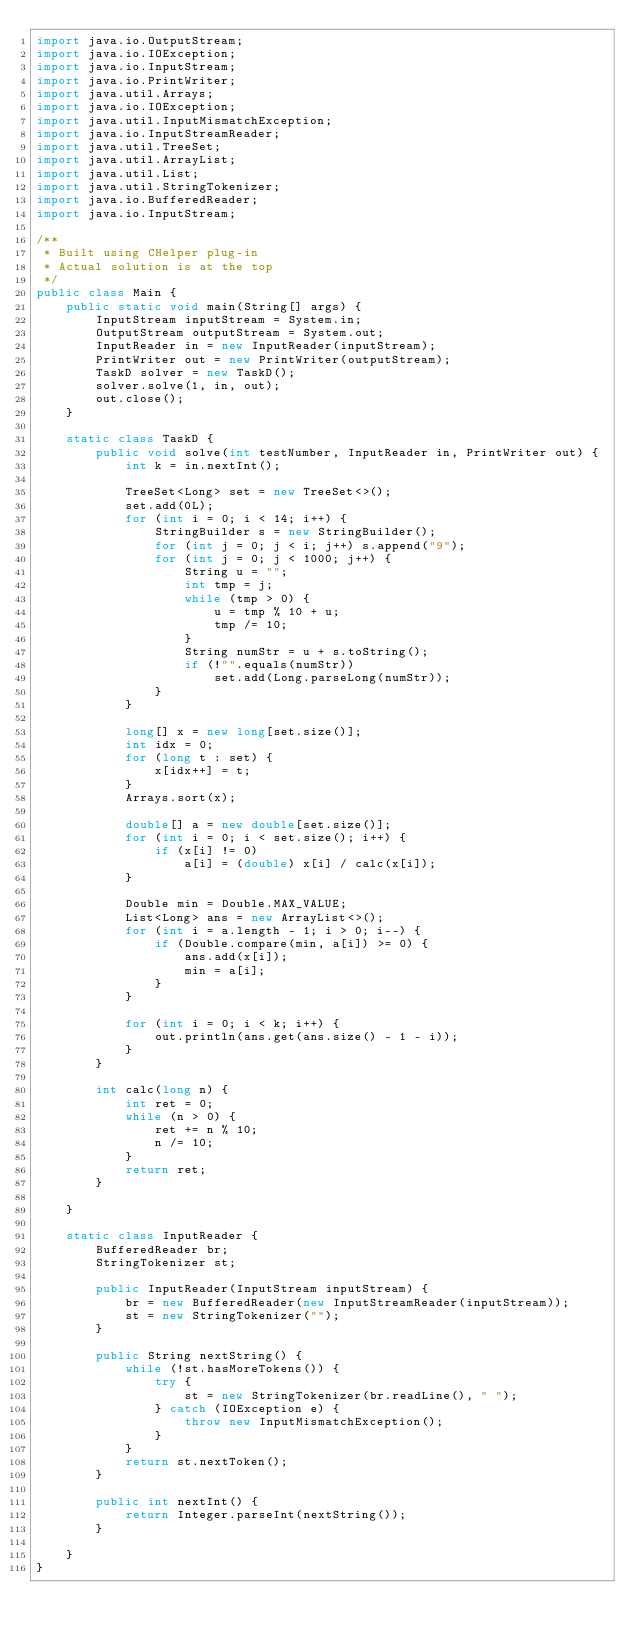<code> <loc_0><loc_0><loc_500><loc_500><_Java_>import java.io.OutputStream;
import java.io.IOException;
import java.io.InputStream;
import java.io.PrintWriter;
import java.util.Arrays;
import java.io.IOException;
import java.util.InputMismatchException;
import java.io.InputStreamReader;
import java.util.TreeSet;
import java.util.ArrayList;
import java.util.List;
import java.util.StringTokenizer;
import java.io.BufferedReader;
import java.io.InputStream;

/**
 * Built using CHelper plug-in
 * Actual solution is at the top
 */
public class Main {
    public static void main(String[] args) {
        InputStream inputStream = System.in;
        OutputStream outputStream = System.out;
        InputReader in = new InputReader(inputStream);
        PrintWriter out = new PrintWriter(outputStream);
        TaskD solver = new TaskD();
        solver.solve(1, in, out);
        out.close();
    }

    static class TaskD {
        public void solve(int testNumber, InputReader in, PrintWriter out) {
            int k = in.nextInt();

            TreeSet<Long> set = new TreeSet<>();
            set.add(0L);
            for (int i = 0; i < 14; i++) {
                StringBuilder s = new StringBuilder();
                for (int j = 0; j < i; j++) s.append("9");
                for (int j = 0; j < 1000; j++) {
                    String u = "";
                    int tmp = j;
                    while (tmp > 0) {
                        u = tmp % 10 + u;
                        tmp /= 10;
                    }
                    String numStr = u + s.toString();
                    if (!"".equals(numStr))
                        set.add(Long.parseLong(numStr));
                }
            }

            long[] x = new long[set.size()];
            int idx = 0;
            for (long t : set) {
                x[idx++] = t;
            }
            Arrays.sort(x);

            double[] a = new double[set.size()];
            for (int i = 0; i < set.size(); i++) {
                if (x[i] != 0)
                    a[i] = (double) x[i] / calc(x[i]);
            }

            Double min = Double.MAX_VALUE;
            List<Long> ans = new ArrayList<>();
            for (int i = a.length - 1; i > 0; i--) {
                if (Double.compare(min, a[i]) >= 0) {
                    ans.add(x[i]);
                    min = a[i];
                }
            }

            for (int i = 0; i < k; i++) {
                out.println(ans.get(ans.size() - 1 - i));
            }
        }

        int calc(long n) {
            int ret = 0;
            while (n > 0) {
                ret += n % 10;
                n /= 10;
            }
            return ret;
        }

    }

    static class InputReader {
        BufferedReader br;
        StringTokenizer st;

        public InputReader(InputStream inputStream) {
            br = new BufferedReader(new InputStreamReader(inputStream));
            st = new StringTokenizer("");
        }

        public String nextString() {
            while (!st.hasMoreTokens()) {
                try {
                    st = new StringTokenizer(br.readLine(), " ");
                } catch (IOException e) {
                    throw new InputMismatchException();
                }
            }
            return st.nextToken();
        }

        public int nextInt() {
            return Integer.parseInt(nextString());
        }

    }
}

</code> 